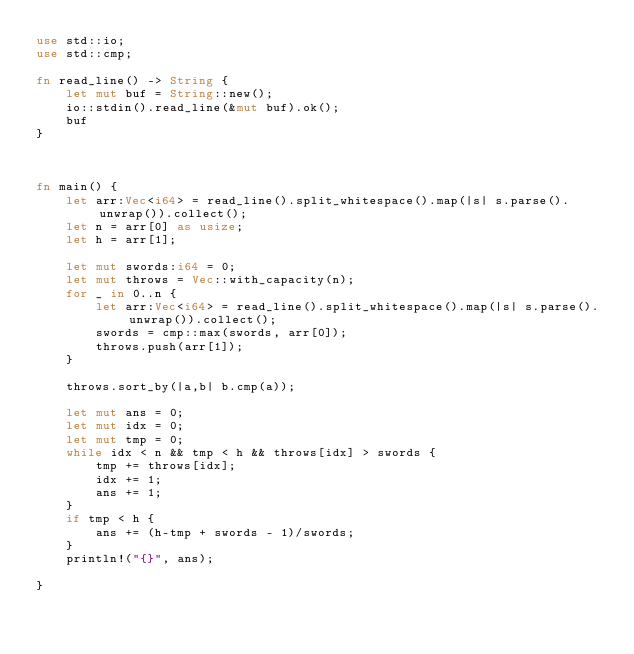<code> <loc_0><loc_0><loc_500><loc_500><_Rust_>use std::io;
use std::cmp;

fn read_line() -> String {
    let mut buf = String::new();
    io::stdin().read_line(&mut buf).ok();
    buf
}



fn main() {
    let arr:Vec<i64> = read_line().split_whitespace().map(|s| s.parse().unwrap()).collect();
    let n = arr[0] as usize;
    let h = arr[1];

    let mut swords:i64 = 0;
    let mut throws = Vec::with_capacity(n);
    for _ in 0..n {
        let arr:Vec<i64> = read_line().split_whitespace().map(|s| s.parse().unwrap()).collect();
        swords = cmp::max(swords, arr[0]);
        throws.push(arr[1]);
    }

    throws.sort_by(|a,b| b.cmp(a));

    let mut ans = 0;
    let mut idx = 0;
    let mut tmp = 0;
    while idx < n && tmp < h && throws[idx] > swords {
        tmp += throws[idx];
        idx += 1;
        ans += 1;
    }
    if tmp < h {
        ans += (h-tmp + swords - 1)/swords;
    }
    println!("{}", ans);

}
</code> 